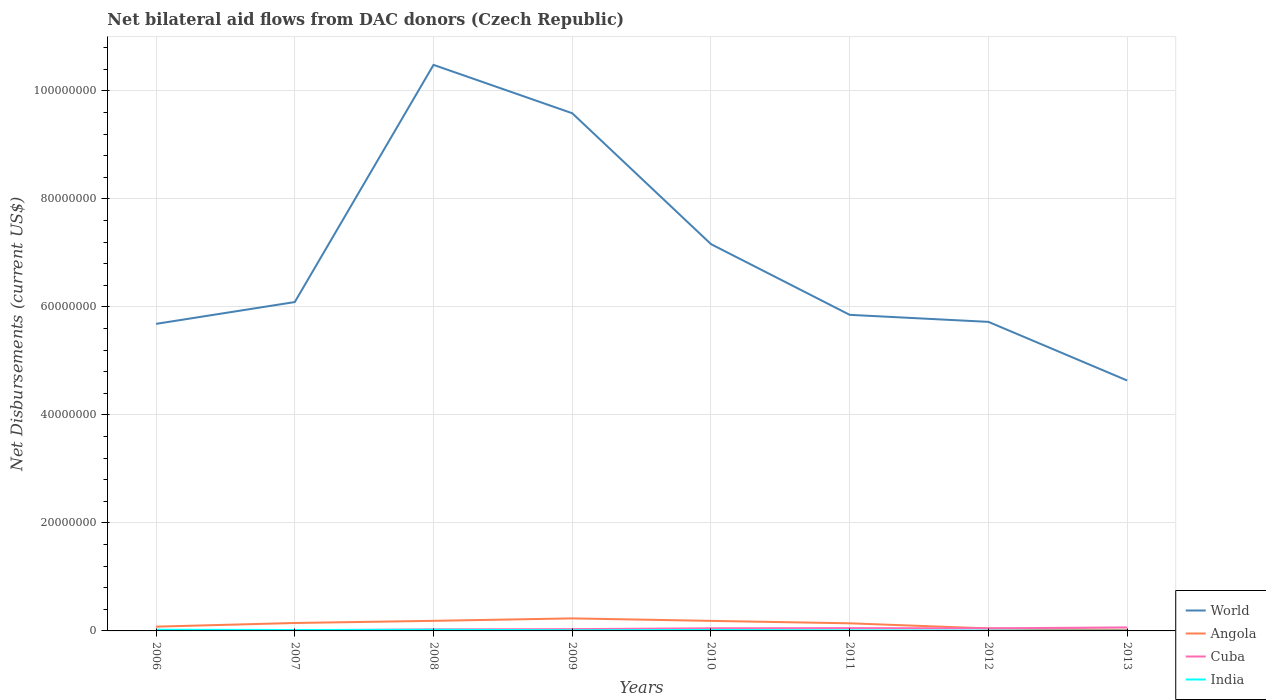How many different coloured lines are there?
Provide a short and direct response. 4. Is the number of lines equal to the number of legend labels?
Give a very brief answer. Yes. Across all years, what is the maximum net bilateral aid flows in World?
Make the answer very short. 4.64e+07. What is the total net bilateral aid flows in World in the graph?
Your answer should be compact. -1.48e+07. What is the difference between the highest and the second highest net bilateral aid flows in World?
Your response must be concise. 5.85e+07. Is the net bilateral aid flows in Angola strictly greater than the net bilateral aid flows in World over the years?
Provide a short and direct response. Yes. How many lines are there?
Offer a very short reply. 4. How many years are there in the graph?
Give a very brief answer. 8. What is the difference between two consecutive major ticks on the Y-axis?
Make the answer very short. 2.00e+07. Are the values on the major ticks of Y-axis written in scientific E-notation?
Your answer should be very brief. No. Does the graph contain grids?
Keep it short and to the point. Yes. How many legend labels are there?
Provide a short and direct response. 4. How are the legend labels stacked?
Offer a terse response. Vertical. What is the title of the graph?
Your answer should be compact. Net bilateral aid flows from DAC donors (Czech Republic). Does "Virgin Islands" appear as one of the legend labels in the graph?
Provide a short and direct response. No. What is the label or title of the X-axis?
Provide a short and direct response. Years. What is the label or title of the Y-axis?
Provide a short and direct response. Net Disbursements (current US$). What is the Net Disbursements (current US$) of World in 2006?
Offer a terse response. 5.69e+07. What is the Net Disbursements (current US$) in Angola in 2006?
Provide a succinct answer. 7.90e+05. What is the Net Disbursements (current US$) in World in 2007?
Keep it short and to the point. 6.09e+07. What is the Net Disbursements (current US$) of Angola in 2007?
Your response must be concise. 1.47e+06. What is the Net Disbursements (current US$) of World in 2008?
Keep it short and to the point. 1.05e+08. What is the Net Disbursements (current US$) of Angola in 2008?
Your response must be concise. 1.87e+06. What is the Net Disbursements (current US$) of World in 2009?
Your answer should be very brief. 9.59e+07. What is the Net Disbursements (current US$) in Angola in 2009?
Provide a short and direct response. 2.32e+06. What is the Net Disbursements (current US$) of World in 2010?
Offer a very short reply. 7.16e+07. What is the Net Disbursements (current US$) in Angola in 2010?
Keep it short and to the point. 1.86e+06. What is the Net Disbursements (current US$) of India in 2010?
Your answer should be very brief. 1.80e+05. What is the Net Disbursements (current US$) in World in 2011?
Your response must be concise. 5.85e+07. What is the Net Disbursements (current US$) of Angola in 2011?
Ensure brevity in your answer.  1.41e+06. What is the Net Disbursements (current US$) in Cuba in 2011?
Provide a short and direct response. 5.20e+05. What is the Net Disbursements (current US$) of India in 2011?
Your answer should be very brief. 1.10e+05. What is the Net Disbursements (current US$) in World in 2012?
Your answer should be very brief. 5.72e+07. What is the Net Disbursements (current US$) of Angola in 2012?
Make the answer very short. 4.60e+05. What is the Net Disbursements (current US$) of World in 2013?
Ensure brevity in your answer.  4.64e+07. What is the Net Disbursements (current US$) in Angola in 2013?
Ensure brevity in your answer.  2.00e+05. What is the Net Disbursements (current US$) in Cuba in 2013?
Your answer should be very brief. 6.50e+05. What is the Net Disbursements (current US$) of India in 2013?
Provide a short and direct response. 5.00e+04. Across all years, what is the maximum Net Disbursements (current US$) of World?
Provide a succinct answer. 1.05e+08. Across all years, what is the maximum Net Disbursements (current US$) in Angola?
Make the answer very short. 2.32e+06. Across all years, what is the maximum Net Disbursements (current US$) in Cuba?
Provide a short and direct response. 6.50e+05. Across all years, what is the maximum Net Disbursements (current US$) of India?
Provide a short and direct response. 2.20e+05. Across all years, what is the minimum Net Disbursements (current US$) of World?
Keep it short and to the point. 4.64e+07. What is the total Net Disbursements (current US$) of World in the graph?
Your answer should be compact. 5.52e+08. What is the total Net Disbursements (current US$) in Angola in the graph?
Make the answer very short. 1.04e+07. What is the total Net Disbursements (current US$) in Cuba in the graph?
Make the answer very short. 2.98e+06. What is the total Net Disbursements (current US$) in India in the graph?
Provide a short and direct response. 1.13e+06. What is the difference between the Net Disbursements (current US$) of World in 2006 and that in 2007?
Offer a terse response. -4.04e+06. What is the difference between the Net Disbursements (current US$) of Angola in 2006 and that in 2007?
Offer a very short reply. -6.80e+05. What is the difference between the Net Disbursements (current US$) of World in 2006 and that in 2008?
Provide a succinct answer. -4.80e+07. What is the difference between the Net Disbursements (current US$) in Angola in 2006 and that in 2008?
Offer a terse response. -1.08e+06. What is the difference between the Net Disbursements (current US$) in Cuba in 2006 and that in 2008?
Ensure brevity in your answer.  -1.80e+05. What is the difference between the Net Disbursements (current US$) in World in 2006 and that in 2009?
Ensure brevity in your answer.  -3.90e+07. What is the difference between the Net Disbursements (current US$) in Angola in 2006 and that in 2009?
Provide a succinct answer. -1.53e+06. What is the difference between the Net Disbursements (current US$) of India in 2006 and that in 2009?
Provide a short and direct response. 1.00e+05. What is the difference between the Net Disbursements (current US$) in World in 2006 and that in 2010?
Give a very brief answer. -1.48e+07. What is the difference between the Net Disbursements (current US$) of Angola in 2006 and that in 2010?
Your answer should be compact. -1.07e+06. What is the difference between the Net Disbursements (current US$) in Cuba in 2006 and that in 2010?
Make the answer very short. -3.80e+05. What is the difference between the Net Disbursements (current US$) in World in 2006 and that in 2011?
Ensure brevity in your answer.  -1.67e+06. What is the difference between the Net Disbursements (current US$) in Angola in 2006 and that in 2011?
Make the answer very short. -6.20e+05. What is the difference between the Net Disbursements (current US$) in Cuba in 2006 and that in 2011?
Offer a terse response. -4.10e+05. What is the difference between the Net Disbursements (current US$) in World in 2006 and that in 2012?
Your response must be concise. -3.70e+05. What is the difference between the Net Disbursements (current US$) in Cuba in 2006 and that in 2012?
Your response must be concise. -3.70e+05. What is the difference between the Net Disbursements (current US$) in India in 2006 and that in 2012?
Ensure brevity in your answer.  1.60e+05. What is the difference between the Net Disbursements (current US$) in World in 2006 and that in 2013?
Ensure brevity in your answer.  1.05e+07. What is the difference between the Net Disbursements (current US$) of Angola in 2006 and that in 2013?
Your answer should be very brief. 5.90e+05. What is the difference between the Net Disbursements (current US$) in Cuba in 2006 and that in 2013?
Your response must be concise. -5.40e+05. What is the difference between the Net Disbursements (current US$) in World in 2007 and that in 2008?
Ensure brevity in your answer.  -4.39e+07. What is the difference between the Net Disbursements (current US$) in Angola in 2007 and that in 2008?
Offer a terse response. -4.00e+05. What is the difference between the Net Disbursements (current US$) in India in 2007 and that in 2008?
Offer a terse response. -5.00e+04. What is the difference between the Net Disbursements (current US$) in World in 2007 and that in 2009?
Offer a very short reply. -3.50e+07. What is the difference between the Net Disbursements (current US$) in Angola in 2007 and that in 2009?
Ensure brevity in your answer.  -8.50e+05. What is the difference between the Net Disbursements (current US$) in Cuba in 2007 and that in 2009?
Your answer should be compact. -2.20e+05. What is the difference between the Net Disbursements (current US$) in World in 2007 and that in 2010?
Your answer should be compact. -1.07e+07. What is the difference between the Net Disbursements (current US$) of Angola in 2007 and that in 2010?
Your answer should be compact. -3.90e+05. What is the difference between the Net Disbursements (current US$) in Cuba in 2007 and that in 2010?
Ensure brevity in your answer.  -3.80e+05. What is the difference between the Net Disbursements (current US$) of World in 2007 and that in 2011?
Offer a terse response. 2.37e+06. What is the difference between the Net Disbursements (current US$) of Angola in 2007 and that in 2011?
Your response must be concise. 6.00e+04. What is the difference between the Net Disbursements (current US$) in Cuba in 2007 and that in 2011?
Your response must be concise. -4.10e+05. What is the difference between the Net Disbursements (current US$) of India in 2007 and that in 2011?
Your answer should be very brief. 6.00e+04. What is the difference between the Net Disbursements (current US$) of World in 2007 and that in 2012?
Offer a terse response. 3.67e+06. What is the difference between the Net Disbursements (current US$) of Angola in 2007 and that in 2012?
Offer a terse response. 1.01e+06. What is the difference between the Net Disbursements (current US$) of Cuba in 2007 and that in 2012?
Ensure brevity in your answer.  -3.70e+05. What is the difference between the Net Disbursements (current US$) of World in 2007 and that in 2013?
Your answer should be compact. 1.45e+07. What is the difference between the Net Disbursements (current US$) in Angola in 2007 and that in 2013?
Give a very brief answer. 1.27e+06. What is the difference between the Net Disbursements (current US$) of Cuba in 2007 and that in 2013?
Provide a succinct answer. -5.40e+05. What is the difference between the Net Disbursements (current US$) in World in 2008 and that in 2009?
Offer a terse response. 8.96e+06. What is the difference between the Net Disbursements (current US$) in Angola in 2008 and that in 2009?
Your response must be concise. -4.50e+05. What is the difference between the Net Disbursements (current US$) of World in 2008 and that in 2010?
Offer a very short reply. 3.32e+07. What is the difference between the Net Disbursements (current US$) of Angola in 2008 and that in 2010?
Provide a succinct answer. 10000. What is the difference between the Net Disbursements (current US$) in Cuba in 2008 and that in 2010?
Offer a very short reply. -2.00e+05. What is the difference between the Net Disbursements (current US$) of India in 2008 and that in 2010?
Provide a succinct answer. 4.00e+04. What is the difference between the Net Disbursements (current US$) of World in 2008 and that in 2011?
Offer a terse response. 4.63e+07. What is the difference between the Net Disbursements (current US$) in Angola in 2008 and that in 2011?
Offer a very short reply. 4.60e+05. What is the difference between the Net Disbursements (current US$) of Cuba in 2008 and that in 2011?
Offer a terse response. -2.30e+05. What is the difference between the Net Disbursements (current US$) of World in 2008 and that in 2012?
Provide a succinct answer. 4.76e+07. What is the difference between the Net Disbursements (current US$) of Angola in 2008 and that in 2012?
Your response must be concise. 1.41e+06. What is the difference between the Net Disbursements (current US$) of World in 2008 and that in 2013?
Make the answer very short. 5.85e+07. What is the difference between the Net Disbursements (current US$) in Angola in 2008 and that in 2013?
Make the answer very short. 1.67e+06. What is the difference between the Net Disbursements (current US$) in Cuba in 2008 and that in 2013?
Your answer should be compact. -3.60e+05. What is the difference between the Net Disbursements (current US$) in India in 2008 and that in 2013?
Ensure brevity in your answer.  1.70e+05. What is the difference between the Net Disbursements (current US$) in World in 2009 and that in 2010?
Keep it short and to the point. 2.42e+07. What is the difference between the Net Disbursements (current US$) of Angola in 2009 and that in 2010?
Your answer should be compact. 4.60e+05. What is the difference between the Net Disbursements (current US$) of Cuba in 2009 and that in 2010?
Give a very brief answer. -1.60e+05. What is the difference between the Net Disbursements (current US$) of World in 2009 and that in 2011?
Provide a succinct answer. 3.73e+07. What is the difference between the Net Disbursements (current US$) of Angola in 2009 and that in 2011?
Offer a very short reply. 9.10e+05. What is the difference between the Net Disbursements (current US$) in Cuba in 2009 and that in 2011?
Ensure brevity in your answer.  -1.90e+05. What is the difference between the Net Disbursements (current US$) of India in 2009 and that in 2011?
Your answer should be compact. 10000. What is the difference between the Net Disbursements (current US$) of World in 2009 and that in 2012?
Your response must be concise. 3.86e+07. What is the difference between the Net Disbursements (current US$) of Angola in 2009 and that in 2012?
Offer a very short reply. 1.86e+06. What is the difference between the Net Disbursements (current US$) of World in 2009 and that in 2013?
Your response must be concise. 4.95e+07. What is the difference between the Net Disbursements (current US$) of Angola in 2009 and that in 2013?
Provide a succinct answer. 2.12e+06. What is the difference between the Net Disbursements (current US$) of Cuba in 2009 and that in 2013?
Offer a terse response. -3.20e+05. What is the difference between the Net Disbursements (current US$) of India in 2009 and that in 2013?
Your response must be concise. 7.00e+04. What is the difference between the Net Disbursements (current US$) in World in 2010 and that in 2011?
Ensure brevity in your answer.  1.31e+07. What is the difference between the Net Disbursements (current US$) in Cuba in 2010 and that in 2011?
Make the answer very short. -3.00e+04. What is the difference between the Net Disbursements (current US$) in India in 2010 and that in 2011?
Keep it short and to the point. 7.00e+04. What is the difference between the Net Disbursements (current US$) in World in 2010 and that in 2012?
Offer a terse response. 1.44e+07. What is the difference between the Net Disbursements (current US$) of Angola in 2010 and that in 2012?
Make the answer very short. 1.40e+06. What is the difference between the Net Disbursements (current US$) of World in 2010 and that in 2013?
Make the answer very short. 2.53e+07. What is the difference between the Net Disbursements (current US$) of Angola in 2010 and that in 2013?
Give a very brief answer. 1.66e+06. What is the difference between the Net Disbursements (current US$) in World in 2011 and that in 2012?
Offer a very short reply. 1.30e+06. What is the difference between the Net Disbursements (current US$) of Angola in 2011 and that in 2012?
Keep it short and to the point. 9.50e+05. What is the difference between the Net Disbursements (current US$) in Cuba in 2011 and that in 2012?
Make the answer very short. 4.00e+04. What is the difference between the Net Disbursements (current US$) of World in 2011 and that in 2013?
Your answer should be compact. 1.22e+07. What is the difference between the Net Disbursements (current US$) in Angola in 2011 and that in 2013?
Offer a very short reply. 1.21e+06. What is the difference between the Net Disbursements (current US$) in Cuba in 2011 and that in 2013?
Provide a succinct answer. -1.30e+05. What is the difference between the Net Disbursements (current US$) in India in 2011 and that in 2013?
Provide a short and direct response. 6.00e+04. What is the difference between the Net Disbursements (current US$) of World in 2012 and that in 2013?
Your response must be concise. 1.09e+07. What is the difference between the Net Disbursements (current US$) of World in 2006 and the Net Disbursements (current US$) of Angola in 2007?
Ensure brevity in your answer.  5.54e+07. What is the difference between the Net Disbursements (current US$) in World in 2006 and the Net Disbursements (current US$) in Cuba in 2007?
Your answer should be compact. 5.68e+07. What is the difference between the Net Disbursements (current US$) of World in 2006 and the Net Disbursements (current US$) of India in 2007?
Make the answer very short. 5.67e+07. What is the difference between the Net Disbursements (current US$) in Angola in 2006 and the Net Disbursements (current US$) in Cuba in 2007?
Provide a short and direct response. 6.80e+05. What is the difference between the Net Disbursements (current US$) in Angola in 2006 and the Net Disbursements (current US$) in India in 2007?
Your answer should be very brief. 6.20e+05. What is the difference between the Net Disbursements (current US$) in World in 2006 and the Net Disbursements (current US$) in Angola in 2008?
Offer a very short reply. 5.50e+07. What is the difference between the Net Disbursements (current US$) of World in 2006 and the Net Disbursements (current US$) of Cuba in 2008?
Offer a very short reply. 5.66e+07. What is the difference between the Net Disbursements (current US$) of World in 2006 and the Net Disbursements (current US$) of India in 2008?
Provide a short and direct response. 5.66e+07. What is the difference between the Net Disbursements (current US$) of Angola in 2006 and the Net Disbursements (current US$) of India in 2008?
Make the answer very short. 5.70e+05. What is the difference between the Net Disbursements (current US$) of Cuba in 2006 and the Net Disbursements (current US$) of India in 2008?
Provide a short and direct response. -1.10e+05. What is the difference between the Net Disbursements (current US$) in World in 2006 and the Net Disbursements (current US$) in Angola in 2009?
Offer a very short reply. 5.46e+07. What is the difference between the Net Disbursements (current US$) in World in 2006 and the Net Disbursements (current US$) in Cuba in 2009?
Offer a terse response. 5.65e+07. What is the difference between the Net Disbursements (current US$) in World in 2006 and the Net Disbursements (current US$) in India in 2009?
Ensure brevity in your answer.  5.68e+07. What is the difference between the Net Disbursements (current US$) in Angola in 2006 and the Net Disbursements (current US$) in Cuba in 2009?
Make the answer very short. 4.60e+05. What is the difference between the Net Disbursements (current US$) of Angola in 2006 and the Net Disbursements (current US$) of India in 2009?
Provide a succinct answer. 6.70e+05. What is the difference between the Net Disbursements (current US$) of World in 2006 and the Net Disbursements (current US$) of Angola in 2010?
Offer a very short reply. 5.50e+07. What is the difference between the Net Disbursements (current US$) in World in 2006 and the Net Disbursements (current US$) in Cuba in 2010?
Offer a very short reply. 5.64e+07. What is the difference between the Net Disbursements (current US$) in World in 2006 and the Net Disbursements (current US$) in India in 2010?
Offer a terse response. 5.67e+07. What is the difference between the Net Disbursements (current US$) in Angola in 2006 and the Net Disbursements (current US$) in Cuba in 2010?
Provide a succinct answer. 3.00e+05. What is the difference between the Net Disbursements (current US$) of Angola in 2006 and the Net Disbursements (current US$) of India in 2010?
Ensure brevity in your answer.  6.10e+05. What is the difference between the Net Disbursements (current US$) of Cuba in 2006 and the Net Disbursements (current US$) of India in 2010?
Ensure brevity in your answer.  -7.00e+04. What is the difference between the Net Disbursements (current US$) in World in 2006 and the Net Disbursements (current US$) in Angola in 2011?
Your response must be concise. 5.55e+07. What is the difference between the Net Disbursements (current US$) in World in 2006 and the Net Disbursements (current US$) in Cuba in 2011?
Ensure brevity in your answer.  5.64e+07. What is the difference between the Net Disbursements (current US$) of World in 2006 and the Net Disbursements (current US$) of India in 2011?
Your response must be concise. 5.68e+07. What is the difference between the Net Disbursements (current US$) of Angola in 2006 and the Net Disbursements (current US$) of Cuba in 2011?
Your response must be concise. 2.70e+05. What is the difference between the Net Disbursements (current US$) in Angola in 2006 and the Net Disbursements (current US$) in India in 2011?
Your answer should be compact. 6.80e+05. What is the difference between the Net Disbursements (current US$) in World in 2006 and the Net Disbursements (current US$) in Angola in 2012?
Give a very brief answer. 5.64e+07. What is the difference between the Net Disbursements (current US$) of World in 2006 and the Net Disbursements (current US$) of Cuba in 2012?
Keep it short and to the point. 5.64e+07. What is the difference between the Net Disbursements (current US$) in World in 2006 and the Net Disbursements (current US$) in India in 2012?
Make the answer very short. 5.68e+07. What is the difference between the Net Disbursements (current US$) in Angola in 2006 and the Net Disbursements (current US$) in Cuba in 2012?
Keep it short and to the point. 3.10e+05. What is the difference between the Net Disbursements (current US$) in Angola in 2006 and the Net Disbursements (current US$) in India in 2012?
Ensure brevity in your answer.  7.30e+05. What is the difference between the Net Disbursements (current US$) of World in 2006 and the Net Disbursements (current US$) of Angola in 2013?
Offer a terse response. 5.67e+07. What is the difference between the Net Disbursements (current US$) in World in 2006 and the Net Disbursements (current US$) in Cuba in 2013?
Your answer should be compact. 5.62e+07. What is the difference between the Net Disbursements (current US$) in World in 2006 and the Net Disbursements (current US$) in India in 2013?
Make the answer very short. 5.68e+07. What is the difference between the Net Disbursements (current US$) in Angola in 2006 and the Net Disbursements (current US$) in India in 2013?
Provide a short and direct response. 7.40e+05. What is the difference between the Net Disbursements (current US$) in Cuba in 2006 and the Net Disbursements (current US$) in India in 2013?
Give a very brief answer. 6.00e+04. What is the difference between the Net Disbursements (current US$) in World in 2007 and the Net Disbursements (current US$) in Angola in 2008?
Offer a terse response. 5.90e+07. What is the difference between the Net Disbursements (current US$) in World in 2007 and the Net Disbursements (current US$) in Cuba in 2008?
Your response must be concise. 6.06e+07. What is the difference between the Net Disbursements (current US$) in World in 2007 and the Net Disbursements (current US$) in India in 2008?
Provide a succinct answer. 6.07e+07. What is the difference between the Net Disbursements (current US$) of Angola in 2007 and the Net Disbursements (current US$) of Cuba in 2008?
Provide a short and direct response. 1.18e+06. What is the difference between the Net Disbursements (current US$) in Angola in 2007 and the Net Disbursements (current US$) in India in 2008?
Offer a very short reply. 1.25e+06. What is the difference between the Net Disbursements (current US$) of World in 2007 and the Net Disbursements (current US$) of Angola in 2009?
Your response must be concise. 5.86e+07. What is the difference between the Net Disbursements (current US$) in World in 2007 and the Net Disbursements (current US$) in Cuba in 2009?
Ensure brevity in your answer.  6.06e+07. What is the difference between the Net Disbursements (current US$) of World in 2007 and the Net Disbursements (current US$) of India in 2009?
Give a very brief answer. 6.08e+07. What is the difference between the Net Disbursements (current US$) of Angola in 2007 and the Net Disbursements (current US$) of Cuba in 2009?
Keep it short and to the point. 1.14e+06. What is the difference between the Net Disbursements (current US$) in Angola in 2007 and the Net Disbursements (current US$) in India in 2009?
Offer a terse response. 1.35e+06. What is the difference between the Net Disbursements (current US$) of World in 2007 and the Net Disbursements (current US$) of Angola in 2010?
Your answer should be very brief. 5.90e+07. What is the difference between the Net Disbursements (current US$) of World in 2007 and the Net Disbursements (current US$) of Cuba in 2010?
Your response must be concise. 6.04e+07. What is the difference between the Net Disbursements (current US$) of World in 2007 and the Net Disbursements (current US$) of India in 2010?
Offer a very short reply. 6.07e+07. What is the difference between the Net Disbursements (current US$) in Angola in 2007 and the Net Disbursements (current US$) in Cuba in 2010?
Keep it short and to the point. 9.80e+05. What is the difference between the Net Disbursements (current US$) in Angola in 2007 and the Net Disbursements (current US$) in India in 2010?
Offer a very short reply. 1.29e+06. What is the difference between the Net Disbursements (current US$) of World in 2007 and the Net Disbursements (current US$) of Angola in 2011?
Your answer should be compact. 5.95e+07. What is the difference between the Net Disbursements (current US$) of World in 2007 and the Net Disbursements (current US$) of Cuba in 2011?
Offer a terse response. 6.04e+07. What is the difference between the Net Disbursements (current US$) of World in 2007 and the Net Disbursements (current US$) of India in 2011?
Give a very brief answer. 6.08e+07. What is the difference between the Net Disbursements (current US$) in Angola in 2007 and the Net Disbursements (current US$) in Cuba in 2011?
Your response must be concise. 9.50e+05. What is the difference between the Net Disbursements (current US$) in Angola in 2007 and the Net Disbursements (current US$) in India in 2011?
Your answer should be very brief. 1.36e+06. What is the difference between the Net Disbursements (current US$) in World in 2007 and the Net Disbursements (current US$) in Angola in 2012?
Ensure brevity in your answer.  6.04e+07. What is the difference between the Net Disbursements (current US$) in World in 2007 and the Net Disbursements (current US$) in Cuba in 2012?
Keep it short and to the point. 6.04e+07. What is the difference between the Net Disbursements (current US$) of World in 2007 and the Net Disbursements (current US$) of India in 2012?
Your answer should be very brief. 6.08e+07. What is the difference between the Net Disbursements (current US$) in Angola in 2007 and the Net Disbursements (current US$) in Cuba in 2012?
Offer a terse response. 9.90e+05. What is the difference between the Net Disbursements (current US$) of Angola in 2007 and the Net Disbursements (current US$) of India in 2012?
Your answer should be very brief. 1.41e+06. What is the difference between the Net Disbursements (current US$) of World in 2007 and the Net Disbursements (current US$) of Angola in 2013?
Provide a succinct answer. 6.07e+07. What is the difference between the Net Disbursements (current US$) of World in 2007 and the Net Disbursements (current US$) of Cuba in 2013?
Your answer should be very brief. 6.03e+07. What is the difference between the Net Disbursements (current US$) of World in 2007 and the Net Disbursements (current US$) of India in 2013?
Your answer should be compact. 6.09e+07. What is the difference between the Net Disbursements (current US$) of Angola in 2007 and the Net Disbursements (current US$) of Cuba in 2013?
Your answer should be very brief. 8.20e+05. What is the difference between the Net Disbursements (current US$) in Angola in 2007 and the Net Disbursements (current US$) in India in 2013?
Provide a succinct answer. 1.42e+06. What is the difference between the Net Disbursements (current US$) of World in 2008 and the Net Disbursements (current US$) of Angola in 2009?
Keep it short and to the point. 1.03e+08. What is the difference between the Net Disbursements (current US$) in World in 2008 and the Net Disbursements (current US$) in Cuba in 2009?
Your answer should be very brief. 1.05e+08. What is the difference between the Net Disbursements (current US$) in World in 2008 and the Net Disbursements (current US$) in India in 2009?
Offer a terse response. 1.05e+08. What is the difference between the Net Disbursements (current US$) of Angola in 2008 and the Net Disbursements (current US$) of Cuba in 2009?
Your response must be concise. 1.54e+06. What is the difference between the Net Disbursements (current US$) in Angola in 2008 and the Net Disbursements (current US$) in India in 2009?
Offer a very short reply. 1.75e+06. What is the difference between the Net Disbursements (current US$) in Cuba in 2008 and the Net Disbursements (current US$) in India in 2009?
Offer a very short reply. 1.70e+05. What is the difference between the Net Disbursements (current US$) in World in 2008 and the Net Disbursements (current US$) in Angola in 2010?
Provide a succinct answer. 1.03e+08. What is the difference between the Net Disbursements (current US$) of World in 2008 and the Net Disbursements (current US$) of Cuba in 2010?
Your response must be concise. 1.04e+08. What is the difference between the Net Disbursements (current US$) of World in 2008 and the Net Disbursements (current US$) of India in 2010?
Your answer should be compact. 1.05e+08. What is the difference between the Net Disbursements (current US$) in Angola in 2008 and the Net Disbursements (current US$) in Cuba in 2010?
Make the answer very short. 1.38e+06. What is the difference between the Net Disbursements (current US$) in Angola in 2008 and the Net Disbursements (current US$) in India in 2010?
Offer a terse response. 1.69e+06. What is the difference between the Net Disbursements (current US$) of Cuba in 2008 and the Net Disbursements (current US$) of India in 2010?
Keep it short and to the point. 1.10e+05. What is the difference between the Net Disbursements (current US$) in World in 2008 and the Net Disbursements (current US$) in Angola in 2011?
Make the answer very short. 1.03e+08. What is the difference between the Net Disbursements (current US$) of World in 2008 and the Net Disbursements (current US$) of Cuba in 2011?
Your answer should be compact. 1.04e+08. What is the difference between the Net Disbursements (current US$) in World in 2008 and the Net Disbursements (current US$) in India in 2011?
Make the answer very short. 1.05e+08. What is the difference between the Net Disbursements (current US$) in Angola in 2008 and the Net Disbursements (current US$) in Cuba in 2011?
Give a very brief answer. 1.35e+06. What is the difference between the Net Disbursements (current US$) of Angola in 2008 and the Net Disbursements (current US$) of India in 2011?
Keep it short and to the point. 1.76e+06. What is the difference between the Net Disbursements (current US$) of Cuba in 2008 and the Net Disbursements (current US$) of India in 2011?
Your answer should be compact. 1.80e+05. What is the difference between the Net Disbursements (current US$) in World in 2008 and the Net Disbursements (current US$) in Angola in 2012?
Keep it short and to the point. 1.04e+08. What is the difference between the Net Disbursements (current US$) in World in 2008 and the Net Disbursements (current US$) in Cuba in 2012?
Provide a short and direct response. 1.04e+08. What is the difference between the Net Disbursements (current US$) in World in 2008 and the Net Disbursements (current US$) in India in 2012?
Your answer should be compact. 1.05e+08. What is the difference between the Net Disbursements (current US$) in Angola in 2008 and the Net Disbursements (current US$) in Cuba in 2012?
Provide a short and direct response. 1.39e+06. What is the difference between the Net Disbursements (current US$) of Angola in 2008 and the Net Disbursements (current US$) of India in 2012?
Make the answer very short. 1.81e+06. What is the difference between the Net Disbursements (current US$) of Cuba in 2008 and the Net Disbursements (current US$) of India in 2012?
Make the answer very short. 2.30e+05. What is the difference between the Net Disbursements (current US$) in World in 2008 and the Net Disbursements (current US$) in Angola in 2013?
Your answer should be very brief. 1.05e+08. What is the difference between the Net Disbursements (current US$) in World in 2008 and the Net Disbursements (current US$) in Cuba in 2013?
Keep it short and to the point. 1.04e+08. What is the difference between the Net Disbursements (current US$) of World in 2008 and the Net Disbursements (current US$) of India in 2013?
Your answer should be compact. 1.05e+08. What is the difference between the Net Disbursements (current US$) of Angola in 2008 and the Net Disbursements (current US$) of Cuba in 2013?
Provide a short and direct response. 1.22e+06. What is the difference between the Net Disbursements (current US$) of Angola in 2008 and the Net Disbursements (current US$) of India in 2013?
Keep it short and to the point. 1.82e+06. What is the difference between the Net Disbursements (current US$) in Cuba in 2008 and the Net Disbursements (current US$) in India in 2013?
Give a very brief answer. 2.40e+05. What is the difference between the Net Disbursements (current US$) of World in 2009 and the Net Disbursements (current US$) of Angola in 2010?
Your answer should be very brief. 9.40e+07. What is the difference between the Net Disbursements (current US$) of World in 2009 and the Net Disbursements (current US$) of Cuba in 2010?
Make the answer very short. 9.54e+07. What is the difference between the Net Disbursements (current US$) of World in 2009 and the Net Disbursements (current US$) of India in 2010?
Your response must be concise. 9.57e+07. What is the difference between the Net Disbursements (current US$) in Angola in 2009 and the Net Disbursements (current US$) in Cuba in 2010?
Keep it short and to the point. 1.83e+06. What is the difference between the Net Disbursements (current US$) in Angola in 2009 and the Net Disbursements (current US$) in India in 2010?
Keep it short and to the point. 2.14e+06. What is the difference between the Net Disbursements (current US$) of Cuba in 2009 and the Net Disbursements (current US$) of India in 2010?
Keep it short and to the point. 1.50e+05. What is the difference between the Net Disbursements (current US$) of World in 2009 and the Net Disbursements (current US$) of Angola in 2011?
Your answer should be very brief. 9.45e+07. What is the difference between the Net Disbursements (current US$) in World in 2009 and the Net Disbursements (current US$) in Cuba in 2011?
Provide a short and direct response. 9.54e+07. What is the difference between the Net Disbursements (current US$) of World in 2009 and the Net Disbursements (current US$) of India in 2011?
Provide a short and direct response. 9.58e+07. What is the difference between the Net Disbursements (current US$) in Angola in 2009 and the Net Disbursements (current US$) in Cuba in 2011?
Your answer should be compact. 1.80e+06. What is the difference between the Net Disbursements (current US$) in Angola in 2009 and the Net Disbursements (current US$) in India in 2011?
Offer a very short reply. 2.21e+06. What is the difference between the Net Disbursements (current US$) of Cuba in 2009 and the Net Disbursements (current US$) of India in 2011?
Your response must be concise. 2.20e+05. What is the difference between the Net Disbursements (current US$) of World in 2009 and the Net Disbursements (current US$) of Angola in 2012?
Offer a very short reply. 9.54e+07. What is the difference between the Net Disbursements (current US$) in World in 2009 and the Net Disbursements (current US$) in Cuba in 2012?
Make the answer very short. 9.54e+07. What is the difference between the Net Disbursements (current US$) in World in 2009 and the Net Disbursements (current US$) in India in 2012?
Make the answer very short. 9.58e+07. What is the difference between the Net Disbursements (current US$) in Angola in 2009 and the Net Disbursements (current US$) in Cuba in 2012?
Give a very brief answer. 1.84e+06. What is the difference between the Net Disbursements (current US$) in Angola in 2009 and the Net Disbursements (current US$) in India in 2012?
Make the answer very short. 2.26e+06. What is the difference between the Net Disbursements (current US$) in Cuba in 2009 and the Net Disbursements (current US$) in India in 2012?
Your answer should be compact. 2.70e+05. What is the difference between the Net Disbursements (current US$) of World in 2009 and the Net Disbursements (current US$) of Angola in 2013?
Keep it short and to the point. 9.57e+07. What is the difference between the Net Disbursements (current US$) of World in 2009 and the Net Disbursements (current US$) of Cuba in 2013?
Keep it short and to the point. 9.52e+07. What is the difference between the Net Disbursements (current US$) in World in 2009 and the Net Disbursements (current US$) in India in 2013?
Make the answer very short. 9.58e+07. What is the difference between the Net Disbursements (current US$) of Angola in 2009 and the Net Disbursements (current US$) of Cuba in 2013?
Offer a very short reply. 1.67e+06. What is the difference between the Net Disbursements (current US$) in Angola in 2009 and the Net Disbursements (current US$) in India in 2013?
Your response must be concise. 2.27e+06. What is the difference between the Net Disbursements (current US$) of Cuba in 2009 and the Net Disbursements (current US$) of India in 2013?
Keep it short and to the point. 2.80e+05. What is the difference between the Net Disbursements (current US$) in World in 2010 and the Net Disbursements (current US$) in Angola in 2011?
Your response must be concise. 7.02e+07. What is the difference between the Net Disbursements (current US$) of World in 2010 and the Net Disbursements (current US$) of Cuba in 2011?
Give a very brief answer. 7.11e+07. What is the difference between the Net Disbursements (current US$) in World in 2010 and the Net Disbursements (current US$) in India in 2011?
Provide a succinct answer. 7.15e+07. What is the difference between the Net Disbursements (current US$) in Angola in 2010 and the Net Disbursements (current US$) in Cuba in 2011?
Keep it short and to the point. 1.34e+06. What is the difference between the Net Disbursements (current US$) in Angola in 2010 and the Net Disbursements (current US$) in India in 2011?
Offer a very short reply. 1.75e+06. What is the difference between the Net Disbursements (current US$) of Cuba in 2010 and the Net Disbursements (current US$) of India in 2011?
Keep it short and to the point. 3.80e+05. What is the difference between the Net Disbursements (current US$) in World in 2010 and the Net Disbursements (current US$) in Angola in 2012?
Give a very brief answer. 7.12e+07. What is the difference between the Net Disbursements (current US$) in World in 2010 and the Net Disbursements (current US$) in Cuba in 2012?
Your answer should be compact. 7.12e+07. What is the difference between the Net Disbursements (current US$) in World in 2010 and the Net Disbursements (current US$) in India in 2012?
Keep it short and to the point. 7.16e+07. What is the difference between the Net Disbursements (current US$) of Angola in 2010 and the Net Disbursements (current US$) of Cuba in 2012?
Make the answer very short. 1.38e+06. What is the difference between the Net Disbursements (current US$) of Angola in 2010 and the Net Disbursements (current US$) of India in 2012?
Your response must be concise. 1.80e+06. What is the difference between the Net Disbursements (current US$) of World in 2010 and the Net Disbursements (current US$) of Angola in 2013?
Keep it short and to the point. 7.14e+07. What is the difference between the Net Disbursements (current US$) of World in 2010 and the Net Disbursements (current US$) of Cuba in 2013?
Your answer should be compact. 7.10e+07. What is the difference between the Net Disbursements (current US$) of World in 2010 and the Net Disbursements (current US$) of India in 2013?
Your answer should be very brief. 7.16e+07. What is the difference between the Net Disbursements (current US$) in Angola in 2010 and the Net Disbursements (current US$) in Cuba in 2013?
Your answer should be compact. 1.21e+06. What is the difference between the Net Disbursements (current US$) of Angola in 2010 and the Net Disbursements (current US$) of India in 2013?
Provide a short and direct response. 1.81e+06. What is the difference between the Net Disbursements (current US$) of Cuba in 2010 and the Net Disbursements (current US$) of India in 2013?
Offer a very short reply. 4.40e+05. What is the difference between the Net Disbursements (current US$) of World in 2011 and the Net Disbursements (current US$) of Angola in 2012?
Offer a terse response. 5.81e+07. What is the difference between the Net Disbursements (current US$) of World in 2011 and the Net Disbursements (current US$) of Cuba in 2012?
Keep it short and to the point. 5.81e+07. What is the difference between the Net Disbursements (current US$) of World in 2011 and the Net Disbursements (current US$) of India in 2012?
Your response must be concise. 5.85e+07. What is the difference between the Net Disbursements (current US$) of Angola in 2011 and the Net Disbursements (current US$) of Cuba in 2012?
Provide a succinct answer. 9.30e+05. What is the difference between the Net Disbursements (current US$) in Angola in 2011 and the Net Disbursements (current US$) in India in 2012?
Offer a very short reply. 1.35e+06. What is the difference between the Net Disbursements (current US$) of World in 2011 and the Net Disbursements (current US$) of Angola in 2013?
Make the answer very short. 5.83e+07. What is the difference between the Net Disbursements (current US$) in World in 2011 and the Net Disbursements (current US$) in Cuba in 2013?
Keep it short and to the point. 5.79e+07. What is the difference between the Net Disbursements (current US$) in World in 2011 and the Net Disbursements (current US$) in India in 2013?
Offer a very short reply. 5.85e+07. What is the difference between the Net Disbursements (current US$) of Angola in 2011 and the Net Disbursements (current US$) of Cuba in 2013?
Give a very brief answer. 7.60e+05. What is the difference between the Net Disbursements (current US$) in Angola in 2011 and the Net Disbursements (current US$) in India in 2013?
Your response must be concise. 1.36e+06. What is the difference between the Net Disbursements (current US$) of Cuba in 2011 and the Net Disbursements (current US$) of India in 2013?
Provide a succinct answer. 4.70e+05. What is the difference between the Net Disbursements (current US$) in World in 2012 and the Net Disbursements (current US$) in Angola in 2013?
Keep it short and to the point. 5.70e+07. What is the difference between the Net Disbursements (current US$) in World in 2012 and the Net Disbursements (current US$) in Cuba in 2013?
Your answer should be very brief. 5.66e+07. What is the difference between the Net Disbursements (current US$) in World in 2012 and the Net Disbursements (current US$) in India in 2013?
Make the answer very short. 5.72e+07. What is the difference between the Net Disbursements (current US$) of Cuba in 2012 and the Net Disbursements (current US$) of India in 2013?
Provide a succinct answer. 4.30e+05. What is the average Net Disbursements (current US$) of World per year?
Make the answer very short. 6.90e+07. What is the average Net Disbursements (current US$) in Angola per year?
Make the answer very short. 1.30e+06. What is the average Net Disbursements (current US$) in Cuba per year?
Provide a short and direct response. 3.72e+05. What is the average Net Disbursements (current US$) in India per year?
Ensure brevity in your answer.  1.41e+05. In the year 2006, what is the difference between the Net Disbursements (current US$) of World and Net Disbursements (current US$) of Angola?
Your answer should be compact. 5.61e+07. In the year 2006, what is the difference between the Net Disbursements (current US$) in World and Net Disbursements (current US$) in Cuba?
Ensure brevity in your answer.  5.68e+07. In the year 2006, what is the difference between the Net Disbursements (current US$) of World and Net Disbursements (current US$) of India?
Provide a succinct answer. 5.66e+07. In the year 2006, what is the difference between the Net Disbursements (current US$) in Angola and Net Disbursements (current US$) in Cuba?
Provide a succinct answer. 6.80e+05. In the year 2006, what is the difference between the Net Disbursements (current US$) in Angola and Net Disbursements (current US$) in India?
Your answer should be very brief. 5.70e+05. In the year 2007, what is the difference between the Net Disbursements (current US$) in World and Net Disbursements (current US$) in Angola?
Give a very brief answer. 5.94e+07. In the year 2007, what is the difference between the Net Disbursements (current US$) of World and Net Disbursements (current US$) of Cuba?
Offer a terse response. 6.08e+07. In the year 2007, what is the difference between the Net Disbursements (current US$) in World and Net Disbursements (current US$) in India?
Make the answer very short. 6.07e+07. In the year 2007, what is the difference between the Net Disbursements (current US$) in Angola and Net Disbursements (current US$) in Cuba?
Provide a short and direct response. 1.36e+06. In the year 2007, what is the difference between the Net Disbursements (current US$) of Angola and Net Disbursements (current US$) of India?
Your answer should be very brief. 1.30e+06. In the year 2008, what is the difference between the Net Disbursements (current US$) of World and Net Disbursements (current US$) of Angola?
Your answer should be compact. 1.03e+08. In the year 2008, what is the difference between the Net Disbursements (current US$) in World and Net Disbursements (current US$) in Cuba?
Make the answer very short. 1.05e+08. In the year 2008, what is the difference between the Net Disbursements (current US$) of World and Net Disbursements (current US$) of India?
Make the answer very short. 1.05e+08. In the year 2008, what is the difference between the Net Disbursements (current US$) in Angola and Net Disbursements (current US$) in Cuba?
Ensure brevity in your answer.  1.58e+06. In the year 2008, what is the difference between the Net Disbursements (current US$) of Angola and Net Disbursements (current US$) of India?
Keep it short and to the point. 1.65e+06. In the year 2008, what is the difference between the Net Disbursements (current US$) of Cuba and Net Disbursements (current US$) of India?
Give a very brief answer. 7.00e+04. In the year 2009, what is the difference between the Net Disbursements (current US$) in World and Net Disbursements (current US$) in Angola?
Your answer should be compact. 9.36e+07. In the year 2009, what is the difference between the Net Disbursements (current US$) of World and Net Disbursements (current US$) of Cuba?
Offer a terse response. 9.56e+07. In the year 2009, what is the difference between the Net Disbursements (current US$) in World and Net Disbursements (current US$) in India?
Keep it short and to the point. 9.58e+07. In the year 2009, what is the difference between the Net Disbursements (current US$) of Angola and Net Disbursements (current US$) of Cuba?
Give a very brief answer. 1.99e+06. In the year 2009, what is the difference between the Net Disbursements (current US$) of Angola and Net Disbursements (current US$) of India?
Make the answer very short. 2.20e+06. In the year 2010, what is the difference between the Net Disbursements (current US$) of World and Net Disbursements (current US$) of Angola?
Your response must be concise. 6.98e+07. In the year 2010, what is the difference between the Net Disbursements (current US$) of World and Net Disbursements (current US$) of Cuba?
Keep it short and to the point. 7.12e+07. In the year 2010, what is the difference between the Net Disbursements (current US$) in World and Net Disbursements (current US$) in India?
Your answer should be compact. 7.15e+07. In the year 2010, what is the difference between the Net Disbursements (current US$) in Angola and Net Disbursements (current US$) in Cuba?
Your response must be concise. 1.37e+06. In the year 2010, what is the difference between the Net Disbursements (current US$) of Angola and Net Disbursements (current US$) of India?
Make the answer very short. 1.68e+06. In the year 2010, what is the difference between the Net Disbursements (current US$) in Cuba and Net Disbursements (current US$) in India?
Provide a succinct answer. 3.10e+05. In the year 2011, what is the difference between the Net Disbursements (current US$) of World and Net Disbursements (current US$) of Angola?
Your response must be concise. 5.71e+07. In the year 2011, what is the difference between the Net Disbursements (current US$) of World and Net Disbursements (current US$) of Cuba?
Make the answer very short. 5.80e+07. In the year 2011, what is the difference between the Net Disbursements (current US$) of World and Net Disbursements (current US$) of India?
Your answer should be compact. 5.84e+07. In the year 2011, what is the difference between the Net Disbursements (current US$) in Angola and Net Disbursements (current US$) in Cuba?
Offer a very short reply. 8.90e+05. In the year 2011, what is the difference between the Net Disbursements (current US$) of Angola and Net Disbursements (current US$) of India?
Your answer should be compact. 1.30e+06. In the year 2011, what is the difference between the Net Disbursements (current US$) in Cuba and Net Disbursements (current US$) in India?
Your answer should be compact. 4.10e+05. In the year 2012, what is the difference between the Net Disbursements (current US$) of World and Net Disbursements (current US$) of Angola?
Keep it short and to the point. 5.68e+07. In the year 2012, what is the difference between the Net Disbursements (current US$) of World and Net Disbursements (current US$) of Cuba?
Give a very brief answer. 5.68e+07. In the year 2012, what is the difference between the Net Disbursements (current US$) in World and Net Disbursements (current US$) in India?
Give a very brief answer. 5.72e+07. In the year 2012, what is the difference between the Net Disbursements (current US$) of Angola and Net Disbursements (current US$) of Cuba?
Your answer should be very brief. -2.00e+04. In the year 2012, what is the difference between the Net Disbursements (current US$) in Cuba and Net Disbursements (current US$) in India?
Offer a terse response. 4.20e+05. In the year 2013, what is the difference between the Net Disbursements (current US$) of World and Net Disbursements (current US$) of Angola?
Offer a terse response. 4.62e+07. In the year 2013, what is the difference between the Net Disbursements (current US$) in World and Net Disbursements (current US$) in Cuba?
Give a very brief answer. 4.57e+07. In the year 2013, what is the difference between the Net Disbursements (current US$) of World and Net Disbursements (current US$) of India?
Keep it short and to the point. 4.63e+07. In the year 2013, what is the difference between the Net Disbursements (current US$) in Angola and Net Disbursements (current US$) in Cuba?
Provide a short and direct response. -4.50e+05. What is the ratio of the Net Disbursements (current US$) of World in 2006 to that in 2007?
Offer a terse response. 0.93. What is the ratio of the Net Disbursements (current US$) in Angola in 2006 to that in 2007?
Ensure brevity in your answer.  0.54. What is the ratio of the Net Disbursements (current US$) of Cuba in 2006 to that in 2007?
Your answer should be compact. 1. What is the ratio of the Net Disbursements (current US$) of India in 2006 to that in 2007?
Keep it short and to the point. 1.29. What is the ratio of the Net Disbursements (current US$) in World in 2006 to that in 2008?
Your answer should be very brief. 0.54. What is the ratio of the Net Disbursements (current US$) in Angola in 2006 to that in 2008?
Keep it short and to the point. 0.42. What is the ratio of the Net Disbursements (current US$) in Cuba in 2006 to that in 2008?
Ensure brevity in your answer.  0.38. What is the ratio of the Net Disbursements (current US$) in World in 2006 to that in 2009?
Your answer should be compact. 0.59. What is the ratio of the Net Disbursements (current US$) in Angola in 2006 to that in 2009?
Give a very brief answer. 0.34. What is the ratio of the Net Disbursements (current US$) in India in 2006 to that in 2009?
Make the answer very short. 1.83. What is the ratio of the Net Disbursements (current US$) in World in 2006 to that in 2010?
Your answer should be compact. 0.79. What is the ratio of the Net Disbursements (current US$) in Angola in 2006 to that in 2010?
Provide a short and direct response. 0.42. What is the ratio of the Net Disbursements (current US$) in Cuba in 2006 to that in 2010?
Your response must be concise. 0.22. What is the ratio of the Net Disbursements (current US$) of India in 2006 to that in 2010?
Ensure brevity in your answer.  1.22. What is the ratio of the Net Disbursements (current US$) of World in 2006 to that in 2011?
Provide a short and direct response. 0.97. What is the ratio of the Net Disbursements (current US$) in Angola in 2006 to that in 2011?
Your answer should be compact. 0.56. What is the ratio of the Net Disbursements (current US$) of Cuba in 2006 to that in 2011?
Your answer should be very brief. 0.21. What is the ratio of the Net Disbursements (current US$) in India in 2006 to that in 2011?
Provide a succinct answer. 2. What is the ratio of the Net Disbursements (current US$) in Angola in 2006 to that in 2012?
Give a very brief answer. 1.72. What is the ratio of the Net Disbursements (current US$) in Cuba in 2006 to that in 2012?
Keep it short and to the point. 0.23. What is the ratio of the Net Disbursements (current US$) of India in 2006 to that in 2012?
Make the answer very short. 3.67. What is the ratio of the Net Disbursements (current US$) of World in 2006 to that in 2013?
Your answer should be very brief. 1.23. What is the ratio of the Net Disbursements (current US$) in Angola in 2006 to that in 2013?
Keep it short and to the point. 3.95. What is the ratio of the Net Disbursements (current US$) in Cuba in 2006 to that in 2013?
Provide a succinct answer. 0.17. What is the ratio of the Net Disbursements (current US$) in World in 2007 to that in 2008?
Provide a short and direct response. 0.58. What is the ratio of the Net Disbursements (current US$) of Angola in 2007 to that in 2008?
Your answer should be compact. 0.79. What is the ratio of the Net Disbursements (current US$) in Cuba in 2007 to that in 2008?
Offer a very short reply. 0.38. What is the ratio of the Net Disbursements (current US$) in India in 2007 to that in 2008?
Provide a short and direct response. 0.77. What is the ratio of the Net Disbursements (current US$) in World in 2007 to that in 2009?
Ensure brevity in your answer.  0.64. What is the ratio of the Net Disbursements (current US$) in Angola in 2007 to that in 2009?
Keep it short and to the point. 0.63. What is the ratio of the Net Disbursements (current US$) of India in 2007 to that in 2009?
Your answer should be very brief. 1.42. What is the ratio of the Net Disbursements (current US$) in World in 2007 to that in 2010?
Offer a terse response. 0.85. What is the ratio of the Net Disbursements (current US$) in Angola in 2007 to that in 2010?
Your answer should be very brief. 0.79. What is the ratio of the Net Disbursements (current US$) in Cuba in 2007 to that in 2010?
Give a very brief answer. 0.22. What is the ratio of the Net Disbursements (current US$) in World in 2007 to that in 2011?
Provide a succinct answer. 1.04. What is the ratio of the Net Disbursements (current US$) in Angola in 2007 to that in 2011?
Provide a short and direct response. 1.04. What is the ratio of the Net Disbursements (current US$) of Cuba in 2007 to that in 2011?
Make the answer very short. 0.21. What is the ratio of the Net Disbursements (current US$) in India in 2007 to that in 2011?
Make the answer very short. 1.55. What is the ratio of the Net Disbursements (current US$) in World in 2007 to that in 2012?
Your answer should be very brief. 1.06. What is the ratio of the Net Disbursements (current US$) in Angola in 2007 to that in 2012?
Your answer should be very brief. 3.2. What is the ratio of the Net Disbursements (current US$) in Cuba in 2007 to that in 2012?
Provide a succinct answer. 0.23. What is the ratio of the Net Disbursements (current US$) of India in 2007 to that in 2012?
Your response must be concise. 2.83. What is the ratio of the Net Disbursements (current US$) of World in 2007 to that in 2013?
Make the answer very short. 1.31. What is the ratio of the Net Disbursements (current US$) of Angola in 2007 to that in 2013?
Provide a succinct answer. 7.35. What is the ratio of the Net Disbursements (current US$) of Cuba in 2007 to that in 2013?
Offer a terse response. 0.17. What is the ratio of the Net Disbursements (current US$) of India in 2007 to that in 2013?
Make the answer very short. 3.4. What is the ratio of the Net Disbursements (current US$) in World in 2008 to that in 2009?
Make the answer very short. 1.09. What is the ratio of the Net Disbursements (current US$) in Angola in 2008 to that in 2009?
Offer a very short reply. 0.81. What is the ratio of the Net Disbursements (current US$) of Cuba in 2008 to that in 2009?
Your answer should be compact. 0.88. What is the ratio of the Net Disbursements (current US$) in India in 2008 to that in 2009?
Provide a succinct answer. 1.83. What is the ratio of the Net Disbursements (current US$) in World in 2008 to that in 2010?
Ensure brevity in your answer.  1.46. What is the ratio of the Net Disbursements (current US$) of Angola in 2008 to that in 2010?
Your response must be concise. 1.01. What is the ratio of the Net Disbursements (current US$) of Cuba in 2008 to that in 2010?
Your response must be concise. 0.59. What is the ratio of the Net Disbursements (current US$) of India in 2008 to that in 2010?
Provide a succinct answer. 1.22. What is the ratio of the Net Disbursements (current US$) of World in 2008 to that in 2011?
Your response must be concise. 1.79. What is the ratio of the Net Disbursements (current US$) of Angola in 2008 to that in 2011?
Offer a terse response. 1.33. What is the ratio of the Net Disbursements (current US$) in Cuba in 2008 to that in 2011?
Offer a very short reply. 0.56. What is the ratio of the Net Disbursements (current US$) of World in 2008 to that in 2012?
Give a very brief answer. 1.83. What is the ratio of the Net Disbursements (current US$) in Angola in 2008 to that in 2012?
Offer a very short reply. 4.07. What is the ratio of the Net Disbursements (current US$) in Cuba in 2008 to that in 2012?
Your response must be concise. 0.6. What is the ratio of the Net Disbursements (current US$) in India in 2008 to that in 2012?
Make the answer very short. 3.67. What is the ratio of the Net Disbursements (current US$) in World in 2008 to that in 2013?
Give a very brief answer. 2.26. What is the ratio of the Net Disbursements (current US$) in Angola in 2008 to that in 2013?
Keep it short and to the point. 9.35. What is the ratio of the Net Disbursements (current US$) in Cuba in 2008 to that in 2013?
Your answer should be very brief. 0.45. What is the ratio of the Net Disbursements (current US$) in World in 2009 to that in 2010?
Offer a terse response. 1.34. What is the ratio of the Net Disbursements (current US$) in Angola in 2009 to that in 2010?
Give a very brief answer. 1.25. What is the ratio of the Net Disbursements (current US$) of Cuba in 2009 to that in 2010?
Provide a succinct answer. 0.67. What is the ratio of the Net Disbursements (current US$) of India in 2009 to that in 2010?
Keep it short and to the point. 0.67. What is the ratio of the Net Disbursements (current US$) of World in 2009 to that in 2011?
Your answer should be compact. 1.64. What is the ratio of the Net Disbursements (current US$) of Angola in 2009 to that in 2011?
Give a very brief answer. 1.65. What is the ratio of the Net Disbursements (current US$) in Cuba in 2009 to that in 2011?
Offer a terse response. 0.63. What is the ratio of the Net Disbursements (current US$) of India in 2009 to that in 2011?
Your answer should be compact. 1.09. What is the ratio of the Net Disbursements (current US$) in World in 2009 to that in 2012?
Ensure brevity in your answer.  1.68. What is the ratio of the Net Disbursements (current US$) of Angola in 2009 to that in 2012?
Offer a terse response. 5.04. What is the ratio of the Net Disbursements (current US$) of Cuba in 2009 to that in 2012?
Ensure brevity in your answer.  0.69. What is the ratio of the Net Disbursements (current US$) of India in 2009 to that in 2012?
Keep it short and to the point. 2. What is the ratio of the Net Disbursements (current US$) in World in 2009 to that in 2013?
Provide a short and direct response. 2.07. What is the ratio of the Net Disbursements (current US$) of Angola in 2009 to that in 2013?
Keep it short and to the point. 11.6. What is the ratio of the Net Disbursements (current US$) of Cuba in 2009 to that in 2013?
Ensure brevity in your answer.  0.51. What is the ratio of the Net Disbursements (current US$) of World in 2010 to that in 2011?
Provide a succinct answer. 1.22. What is the ratio of the Net Disbursements (current US$) in Angola in 2010 to that in 2011?
Make the answer very short. 1.32. What is the ratio of the Net Disbursements (current US$) in Cuba in 2010 to that in 2011?
Give a very brief answer. 0.94. What is the ratio of the Net Disbursements (current US$) in India in 2010 to that in 2011?
Make the answer very short. 1.64. What is the ratio of the Net Disbursements (current US$) of World in 2010 to that in 2012?
Your response must be concise. 1.25. What is the ratio of the Net Disbursements (current US$) in Angola in 2010 to that in 2012?
Make the answer very short. 4.04. What is the ratio of the Net Disbursements (current US$) of Cuba in 2010 to that in 2012?
Provide a succinct answer. 1.02. What is the ratio of the Net Disbursements (current US$) in India in 2010 to that in 2012?
Provide a short and direct response. 3. What is the ratio of the Net Disbursements (current US$) in World in 2010 to that in 2013?
Your answer should be very brief. 1.54. What is the ratio of the Net Disbursements (current US$) of Angola in 2010 to that in 2013?
Keep it short and to the point. 9.3. What is the ratio of the Net Disbursements (current US$) in Cuba in 2010 to that in 2013?
Your response must be concise. 0.75. What is the ratio of the Net Disbursements (current US$) in India in 2010 to that in 2013?
Your response must be concise. 3.6. What is the ratio of the Net Disbursements (current US$) in World in 2011 to that in 2012?
Make the answer very short. 1.02. What is the ratio of the Net Disbursements (current US$) in Angola in 2011 to that in 2012?
Make the answer very short. 3.07. What is the ratio of the Net Disbursements (current US$) of Cuba in 2011 to that in 2012?
Offer a very short reply. 1.08. What is the ratio of the Net Disbursements (current US$) of India in 2011 to that in 2012?
Offer a terse response. 1.83. What is the ratio of the Net Disbursements (current US$) in World in 2011 to that in 2013?
Your answer should be very brief. 1.26. What is the ratio of the Net Disbursements (current US$) in Angola in 2011 to that in 2013?
Provide a succinct answer. 7.05. What is the ratio of the Net Disbursements (current US$) in India in 2011 to that in 2013?
Ensure brevity in your answer.  2.2. What is the ratio of the Net Disbursements (current US$) in World in 2012 to that in 2013?
Your answer should be compact. 1.23. What is the ratio of the Net Disbursements (current US$) of Cuba in 2012 to that in 2013?
Make the answer very short. 0.74. What is the ratio of the Net Disbursements (current US$) of India in 2012 to that in 2013?
Your answer should be compact. 1.2. What is the difference between the highest and the second highest Net Disbursements (current US$) in World?
Make the answer very short. 8.96e+06. What is the difference between the highest and the second highest Net Disbursements (current US$) in Angola?
Keep it short and to the point. 4.50e+05. What is the difference between the highest and the second highest Net Disbursements (current US$) of India?
Make the answer very short. 0. What is the difference between the highest and the lowest Net Disbursements (current US$) of World?
Offer a terse response. 5.85e+07. What is the difference between the highest and the lowest Net Disbursements (current US$) in Angola?
Give a very brief answer. 2.12e+06. What is the difference between the highest and the lowest Net Disbursements (current US$) in Cuba?
Offer a terse response. 5.40e+05. What is the difference between the highest and the lowest Net Disbursements (current US$) in India?
Offer a terse response. 1.70e+05. 